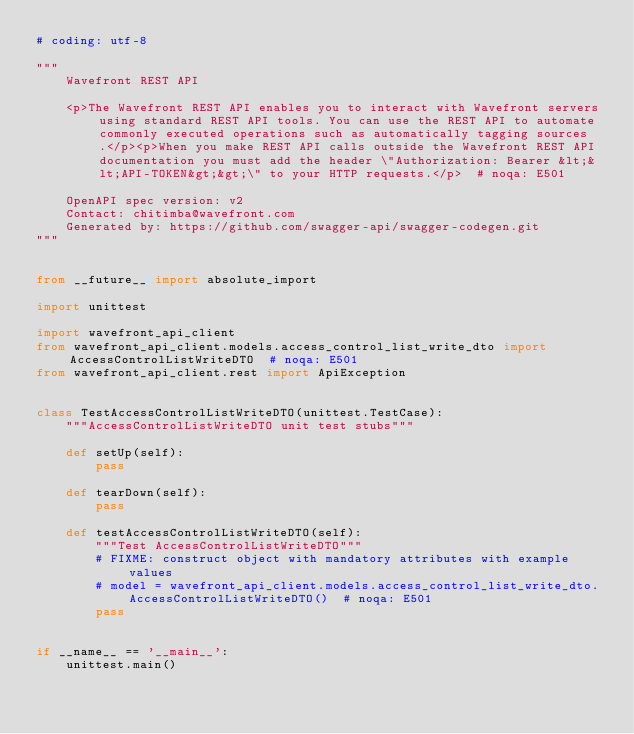Convert code to text. <code><loc_0><loc_0><loc_500><loc_500><_Python_># coding: utf-8

"""
    Wavefront REST API

    <p>The Wavefront REST API enables you to interact with Wavefront servers using standard REST API tools. You can use the REST API to automate commonly executed operations such as automatically tagging sources.</p><p>When you make REST API calls outside the Wavefront REST API documentation you must add the header \"Authorization: Bearer &lt;&lt;API-TOKEN&gt;&gt;\" to your HTTP requests.</p>  # noqa: E501

    OpenAPI spec version: v2
    Contact: chitimba@wavefront.com
    Generated by: https://github.com/swagger-api/swagger-codegen.git
"""


from __future__ import absolute_import

import unittest

import wavefront_api_client
from wavefront_api_client.models.access_control_list_write_dto import AccessControlListWriteDTO  # noqa: E501
from wavefront_api_client.rest import ApiException


class TestAccessControlListWriteDTO(unittest.TestCase):
    """AccessControlListWriteDTO unit test stubs"""

    def setUp(self):
        pass

    def tearDown(self):
        pass

    def testAccessControlListWriteDTO(self):
        """Test AccessControlListWriteDTO"""
        # FIXME: construct object with mandatory attributes with example values
        # model = wavefront_api_client.models.access_control_list_write_dto.AccessControlListWriteDTO()  # noqa: E501
        pass


if __name__ == '__main__':
    unittest.main()
</code> 